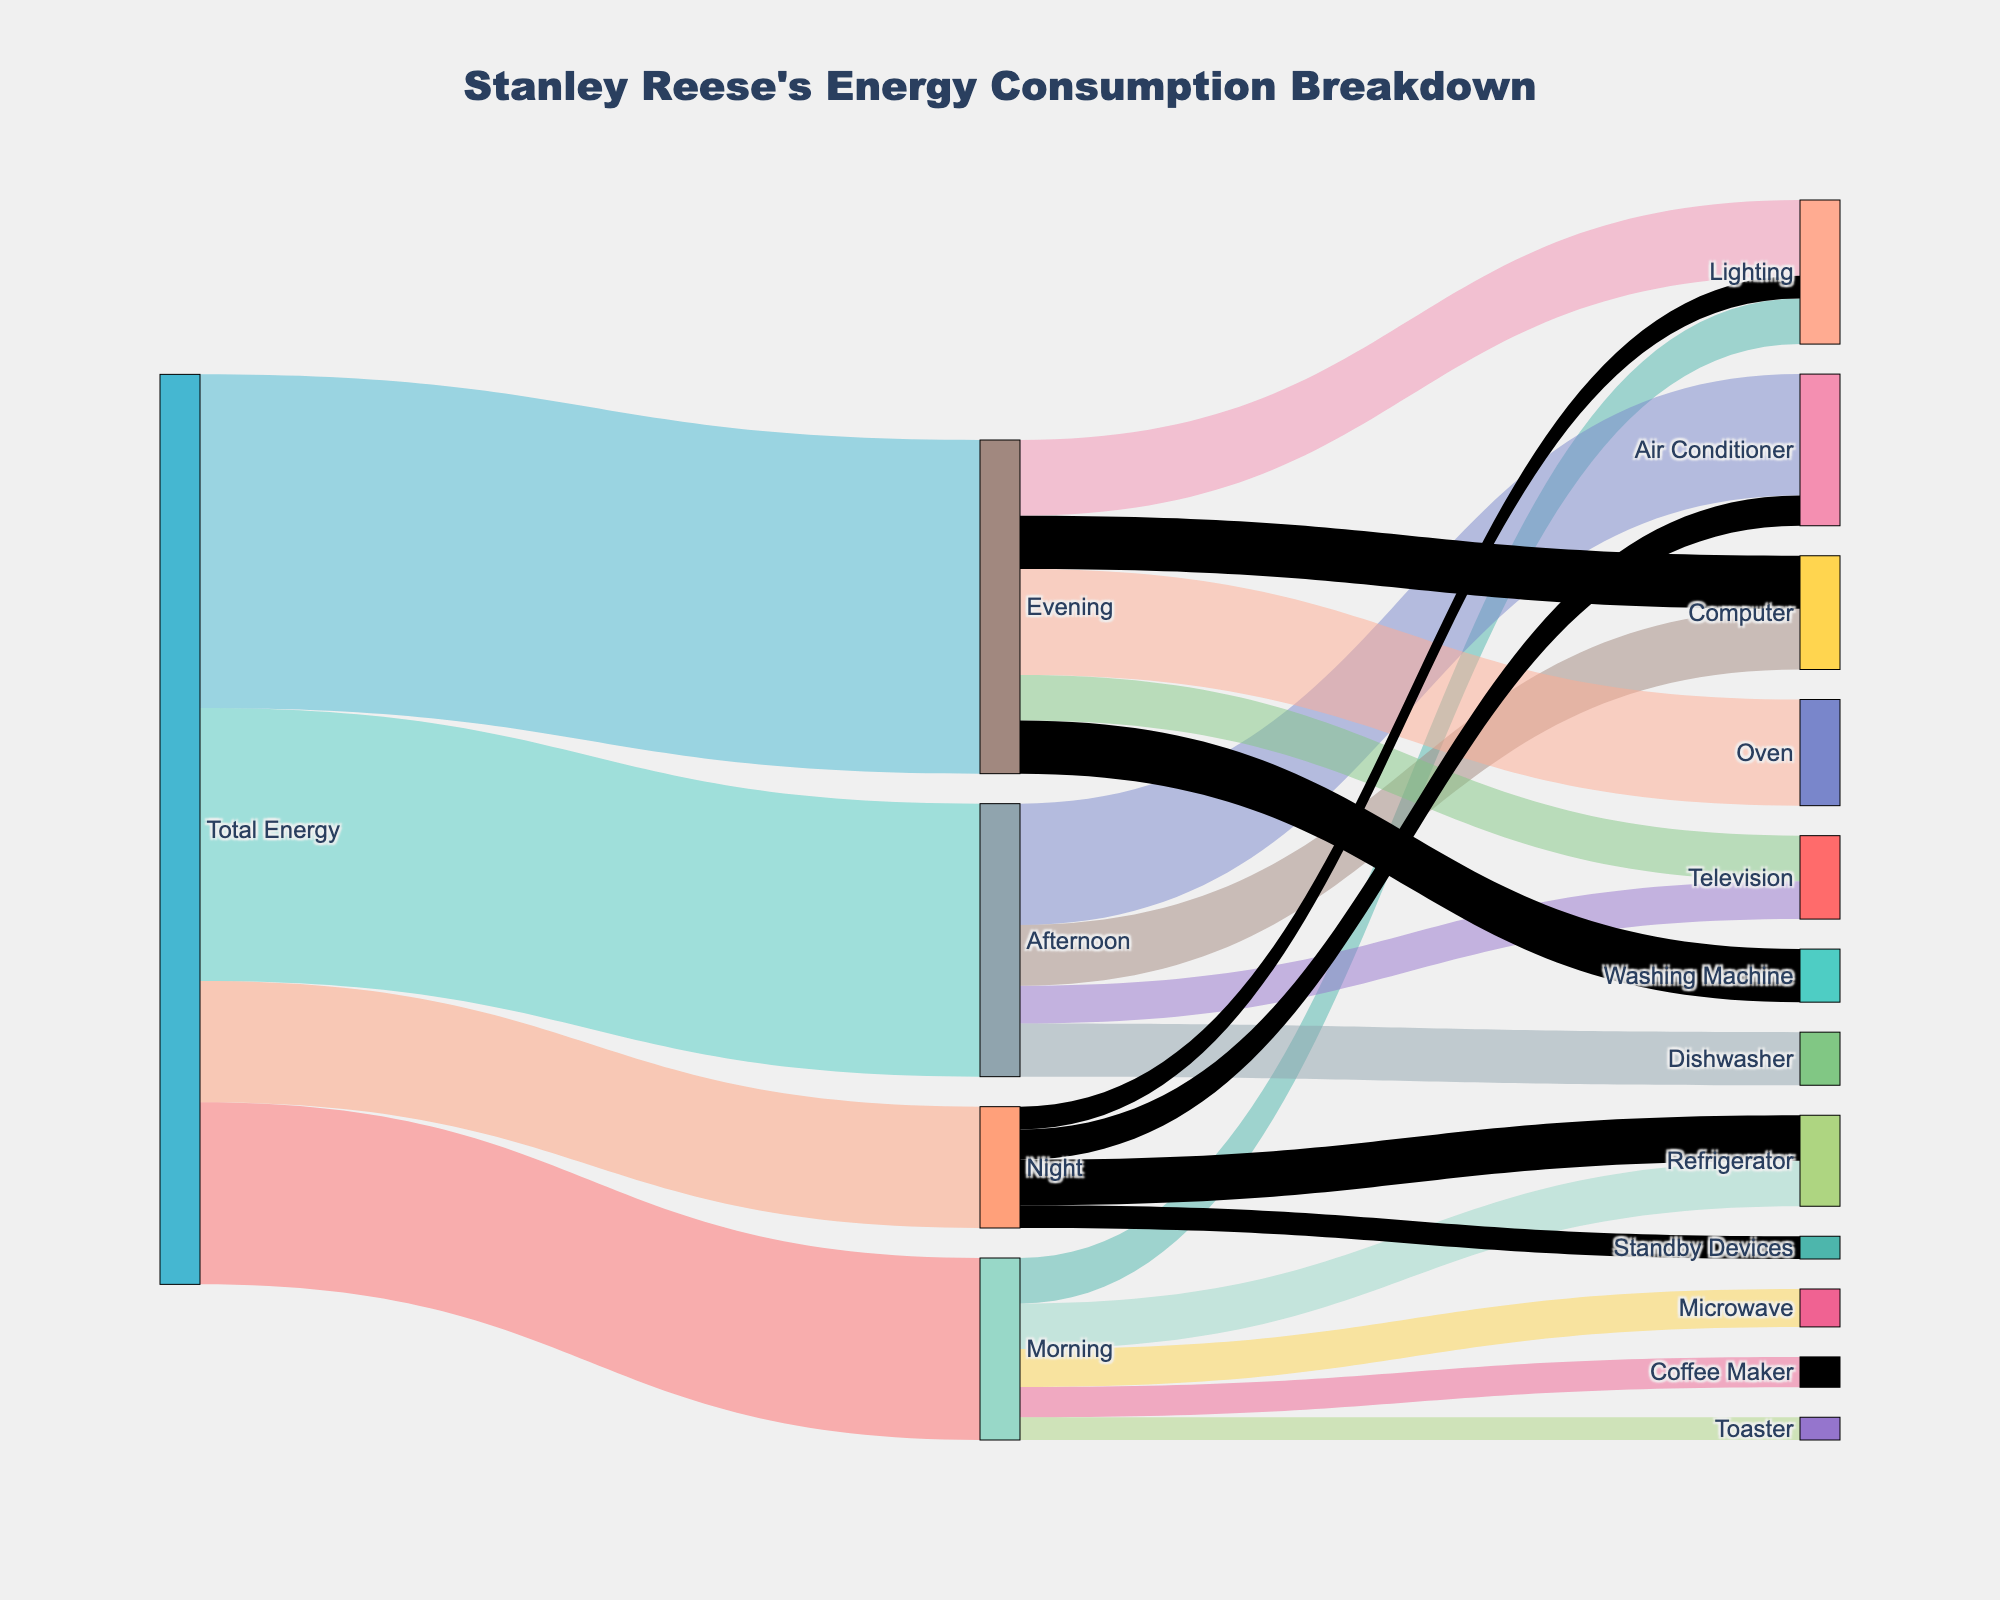What is the total energy consumption for the morning? The total energy consumption for the morning is shown by the link connecting "Total Energy" and "Morning" in the Sankey diagram. The value of this link is 120.
Answer: 120 What are the appliances consuming energy in the afternoon, and how much do they consume? The sink nodes under "Afternoon" display the appliances and their corresponding energy consumption values: Air Conditioner (80), Television (25), Computer (40), and Dishwasher (35).
Answer: Air Conditioner (80), Television (25), Computer (40), Dishwasher (35) Which time of day has the highest total energy consumption? By comparing the links from "Total Energy" to different times of day, we see that the highest value is for the evening, which is 220.
Answer: Evening What is the combined energy consumption of the refrigerator throughout the day? The energy consumption of the refrigerator can be summed from its values in different time slots: Morning (30) + Night (30). So, the combined consumption is 30 + 30.
Answer: 60 How much more energy does the air conditioner consume in the afternoon than at night? The air conditioner consumes 80 during the afternoon and 20 at night. The difference is 80 - 20.
Answer: 60 Which evening appliance uses the least energy, and how much? The appliances in the evening and their energy consumption values are: Oven (70), Lighting (50), Television (30), Computer (35), Washing Machine (35). The television uses the least energy at 30.
Answer: Television, 30 What is the total energy consumption for lighting throughout the day? The energy consumption of lighting can be summed from its values in different time slots: Morning (30), Evening (50), Night (15). So, the total consumption is 30 + 50 + 15.
Answer: 95 Which appliance has the highest energy consumption, and during which time? By examining the sink nodes, the air conditioner during the afternoon has the highest energy consumption of 80.
Answer: Air Conditioner, Afternoon How does the morning energy consumption for the microwave compare to the toaster? The energy consumption for the microwave in the morning is 25, and for the toaster, it is 15. Thus, the microwave uses more energy than the toaster.
Answer: Microwave uses more What is the ratio of total evening energy consumption to total night energy consumption? The total energy consumption in the evening is 220, and at night is 80. So, the ratio is 220/80, which simplifies to 11/4 or 2.75.
Answer: 2.75 